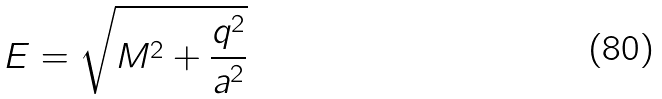Convert formula to latex. <formula><loc_0><loc_0><loc_500><loc_500>E = \sqrt { M ^ { 2 } + \frac { q ^ { 2 } } { a ^ { 2 } } } \,</formula> 